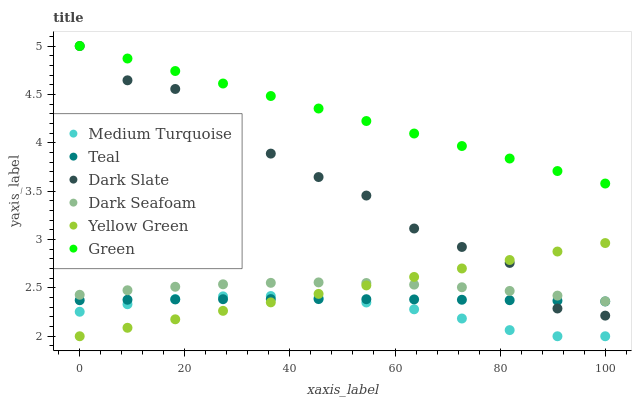Does Medium Turquoise have the minimum area under the curve?
Answer yes or no. Yes. Does Green have the maximum area under the curve?
Answer yes or no. Yes. Does Dark Slate have the minimum area under the curve?
Answer yes or no. No. Does Dark Slate have the maximum area under the curve?
Answer yes or no. No. Is Yellow Green the smoothest?
Answer yes or no. Yes. Is Dark Slate the roughest?
Answer yes or no. Yes. Is Dark Seafoam the smoothest?
Answer yes or no. No. Is Dark Seafoam the roughest?
Answer yes or no. No. Does Medium Turquoise have the lowest value?
Answer yes or no. Yes. Does Dark Slate have the lowest value?
Answer yes or no. No. Does Green have the highest value?
Answer yes or no. Yes. Does Dark Seafoam have the highest value?
Answer yes or no. No. Is Yellow Green less than Green?
Answer yes or no. Yes. Is Green greater than Dark Seafoam?
Answer yes or no. Yes. Does Dark Slate intersect Teal?
Answer yes or no. Yes. Is Dark Slate less than Teal?
Answer yes or no. No. Is Dark Slate greater than Teal?
Answer yes or no. No. Does Yellow Green intersect Green?
Answer yes or no. No. 